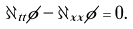Convert formula to latex. <formula><loc_0><loc_0><loc_500><loc_500>\partial _ { t t } \phi - \partial _ { x x } \phi = 0 .</formula> 